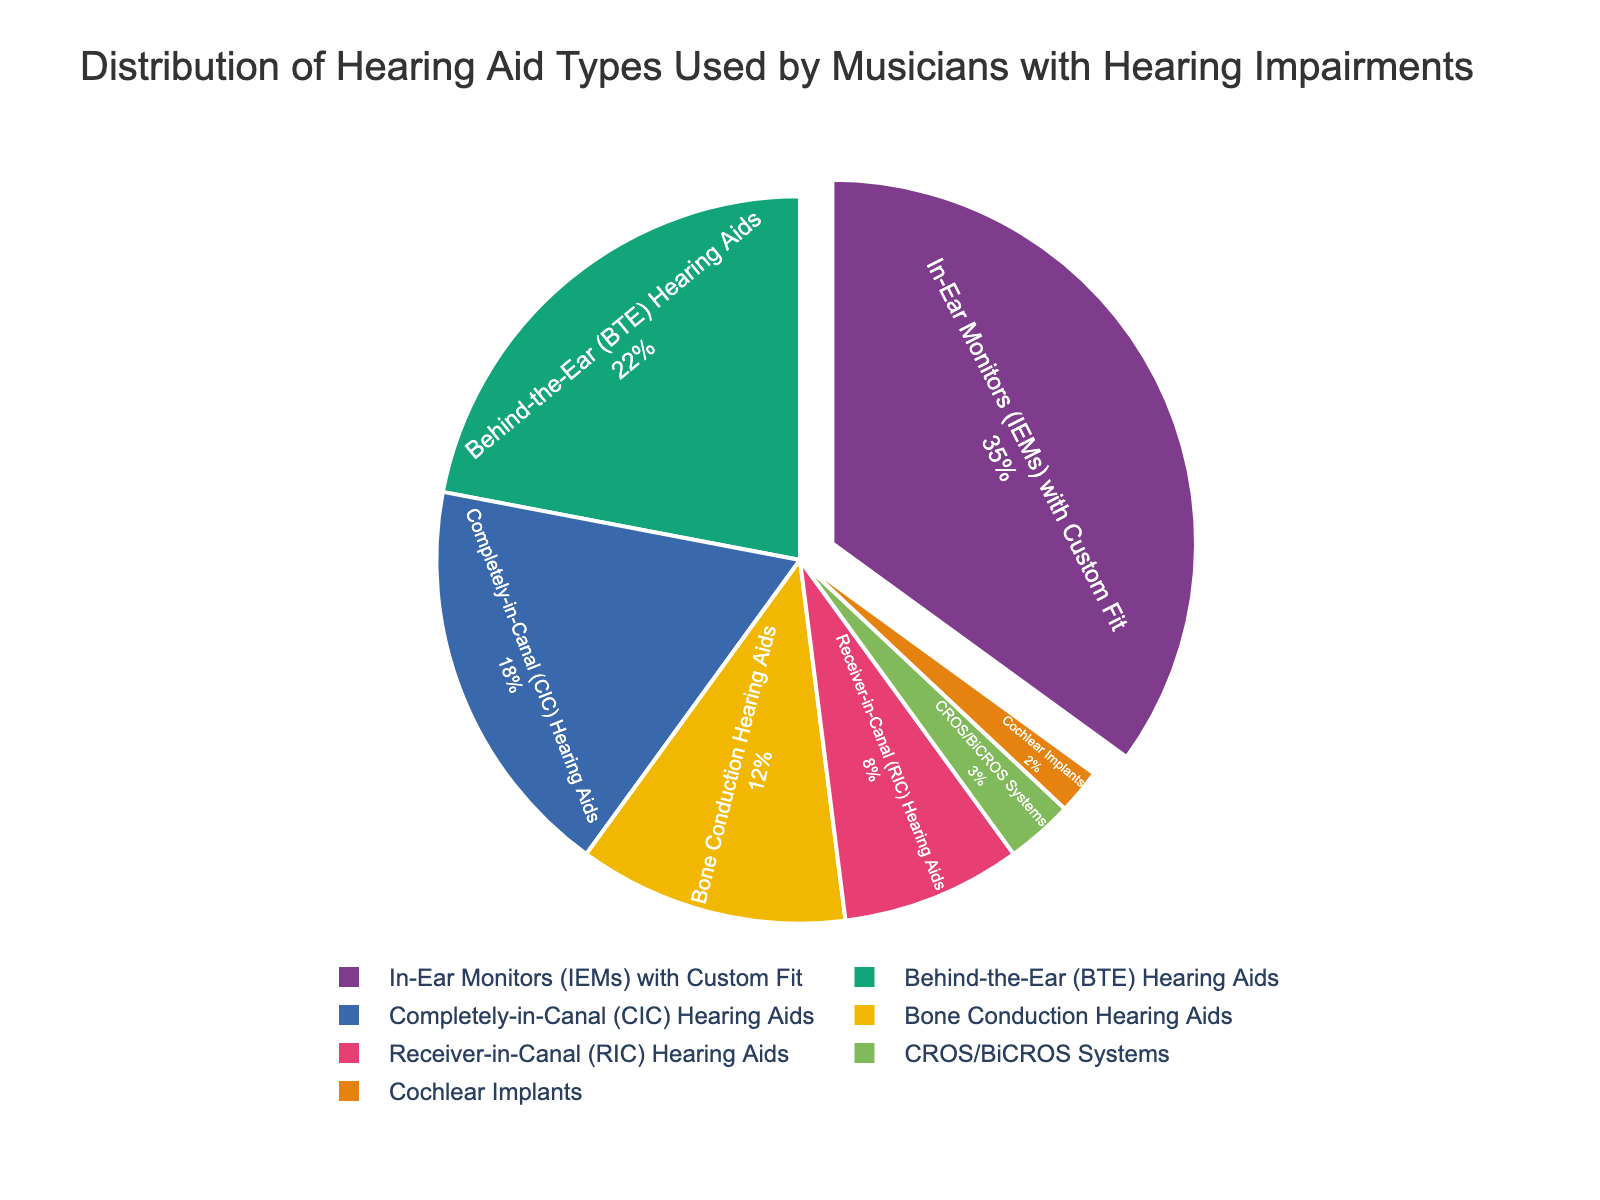What is the most commonly used type of hearing aid among musicians with hearing impairments? The most commonly used type of hearing aid is identified by finding the segment with the largest percentage on the pie chart. In-Ear Monitors (IEMs) with Custom Fit have the largest percentage.
Answer: In-Ear Monitors (IEMs) with Custom Fit How much more popular are Behind-the-Ear (BTE) Hearing Aids than Completely-in-Canal (CIC) Hearing Aids? To find the difference in popularity, subtract the percentage of Completely-in-Canal (CIC) Hearing Aids from Behind-the-Ear (BTE) Hearing Aids. 22% - 18% = 4%
Answer: 4% What percentage of musicians use either Bone Conduction Hearing Aids or Receiver-in-Canal (RIC) Hearing Aids? To determine the overall percentage using either type, sum the percentages of Bone Conduction Hearing Aids and Receiver-in-Canal (RIC) Hearing Aids. 12% + 8% = 20%
Answer: 20% Which hearing aid type is used by the smallest percentage of musicians, and what is that percentage? From the pie chart, look for the smallest segment to identify the hearing aid type with the lowest percentage. Cochlear Implants have the smallest percentage.
Answer: Cochlear Implants, 2% Do more than half of the musicians use In-Ear Monitors (IEMs) with Custom Fit and Behind-the-Ear (BTE) Hearing Aids combined? To check if more than half use these types, sum their percentages and compare to 50%. 35% + 22% = 57%, which is greater than 50%.
Answer: Yes, 57% What is the combined percentage of all hearing aid types, excluding In-Ear Monitors (IEMs) with Custom Fit? Subtract the percentage of IEMs from the total (100%). 100% - 35% = 65%
Answer: 65% Among the hearing aid types, which two have the closest usage percentages? Compare the percentages of all pairs and identify the two closest. Completely-in-Canal (CIC) Hearing Aids and Bone Conduction Hearing Aids have percentages of 18% and 12%, respectively, making the difference 6%, which is the smallest difference among all pairs.
Answer: Completely-in-Canal (CIC) Hearing Aids and Bone Conduction Hearing Aids How does the usage of Behind-the-Ear (BTE) Hearing Aids compare to CROS/BiCROS Systems? Compare the percentages directly. Behind-the-Ear (BTE) Hearing Aids have 22% while CROS/BiCROS Systems have 3%.
Answer: Behind-the-Ear (BTE) Hearing Aids are much more common What is the total percentage of musicians using either Completely-in-Canal (CIC) Hearing Aids, Bone Conduction Hearing Aids, or Cochlear Implants? To determine the total, sum the percentages of all three types. 18% + 12% + 2% = 32%
Answer: 32% Which hearing aid type has a usage percentage equal to half the percentage of In-Ear Monitors (IEMs) with Custom Fit? Find In-Ear Monitors (IEMs) with Custom Fit's percentage (35%) and divide by 2 to get 17.5%. The closest category, though not exactly half, would be Completely-in-Canal (CIC) Hearing Aids at 18%.
Answer: Completely-in-Canal (CIC) Hearing Aids 